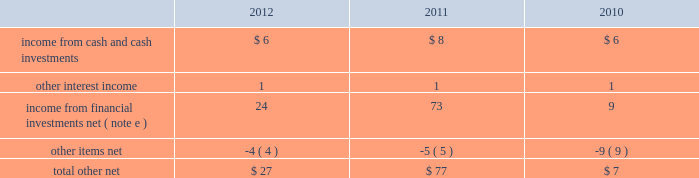Masco corporation notes to consolidated financial statements ( continued ) o .
Segment information ( continued ) ( 1 ) included in net sales were export sales from the u.s .
Of $ 229 million , $ 241 million and $ 246 million in 2012 , 2011 and 2010 , respectively .
( 2 ) excluded from net sales were intra-company sales between segments of approximately two percent of net sales in each of 2012 , 2011 and 2010 .
( 3 ) included in net sales were sales to one customer of $ 2143 million , $ 1984 million and $ 1993 million in 2012 , 2011 and 2010 , respectively .
Such net sales were included in the following segments : cabinets and related products , plumbing products , decorative architectural products and other specialty products .
( 4 ) net sales from the company 2019s operations in the u.s .
Were $ 5793 million , $ 5394 million and $ 5618 million in 2012 , 2011 and 2010 , respectively .
( 5 ) net sales , operating ( loss ) profit , property additions and depreciation and amortization expense for 2012 , 2011 and 2010 excluded the results of businesses reported as discontinued operations in 2012 , 2011 and 2010 .
( 6 ) included in segment operating profit ( loss ) for 2012 was an impairment charge for other intangible assets as follows : other specialty products 2013 $ 42 million .
Included in segment operating ( loss ) profit for 2011 were impairment charges for goodwill and other intangible assets as follows : cabinets and related products 2013 $ 44 million ; plumbing products 2013 $ 1 million ; decorative architectural products 2013 $ 75 million ; and other specialty products 2013 $ 374 million .
Included in segment operating ( loss ) profit for 2010 were impairment charges for goodwill and other intangible assets as follows : plumbing products 2013 $ 1 million ; and installation and other services 2013 $ 697 million .
( 7 ) general corporate expense , net included those expenses not specifically attributable to the company 2019s segments .
( 8 ) the charge for litigation settlement , net in 2012 primarily relates to a business in the installation and other services segment and in 2011 relates to business units in the cabinets and related products and the other specialty products segments .
( 9 ) long-lived assets of the company 2019s operations in the u.s .
And europe were $ 2795 million and $ 567 million , $ 2964 million and $ 565 million , and $ 3684 million and $ 617 million at december 31 , 2012 , 2011 and 2010 , respectively .
( 10 ) segment assets for 2012 and 2011 excluded the assets of businesses reported as discontinued operations in the respective years .
Severance costs as part of the company 2019s continuing review of its operations , actions were taken during 2012 , 2011 and 2010 to respond to market conditions .
The company recorded charges related to severance and early retirement programs of $ 36 million , $ 17 million and $ 14 million for the years ended december 31 , 2012 , 2011 and 2010 , respectively .
Such charges are principally reflected in the statement of operations in selling , general and administrative expenses and were paid when incurred .
Other income ( expense ) , net other , net , which is included in other income ( expense ) , net , was as follows , in millions: .
Other items , net , included realized foreign currency transaction losses of $ 2 million , $ 5 million and $ 2 million in 2012 , 2011 and 2010 , respectively , as well as other miscellaneous items. .
What was the percent of the increase in the company recorded charges related to severance and early retirement programs from 2011 to 2012? 
Rationale: the company recorded an increase of 112% in charges related to severance and early retirement programs from 2011 to 2012
Computations: ((36 - 17) / 17)
Answer: 1.11765. 